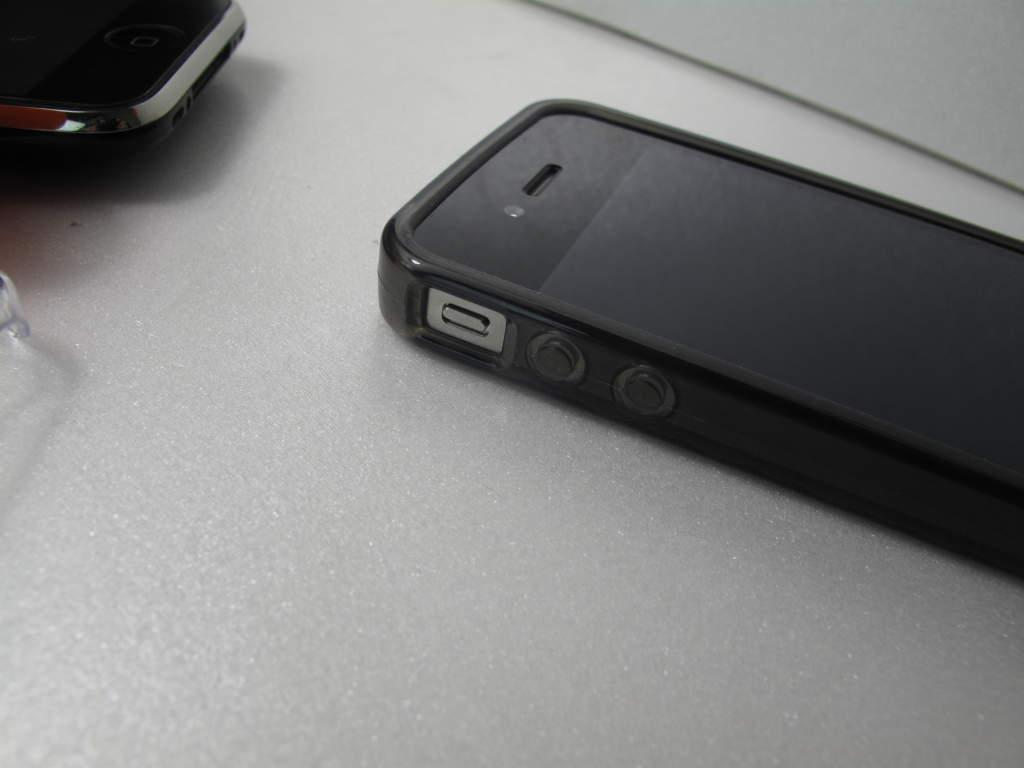How many phones are visible in the image? There are two black color phones in the image. Can you describe the additional object in the image? Unfortunately, the provided facts do not specify the nature of the additional object in the image. What color are the phones in the image? The phones in the image are black. What type of shade does the snail provide in the image? There is no snail present in the image, so it cannot provide any shade. 